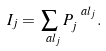<formula> <loc_0><loc_0><loc_500><loc_500>I _ { j } = \sum _ { \ a l _ { j } } P ^ { \ a l _ { j } } _ { j } .</formula> 